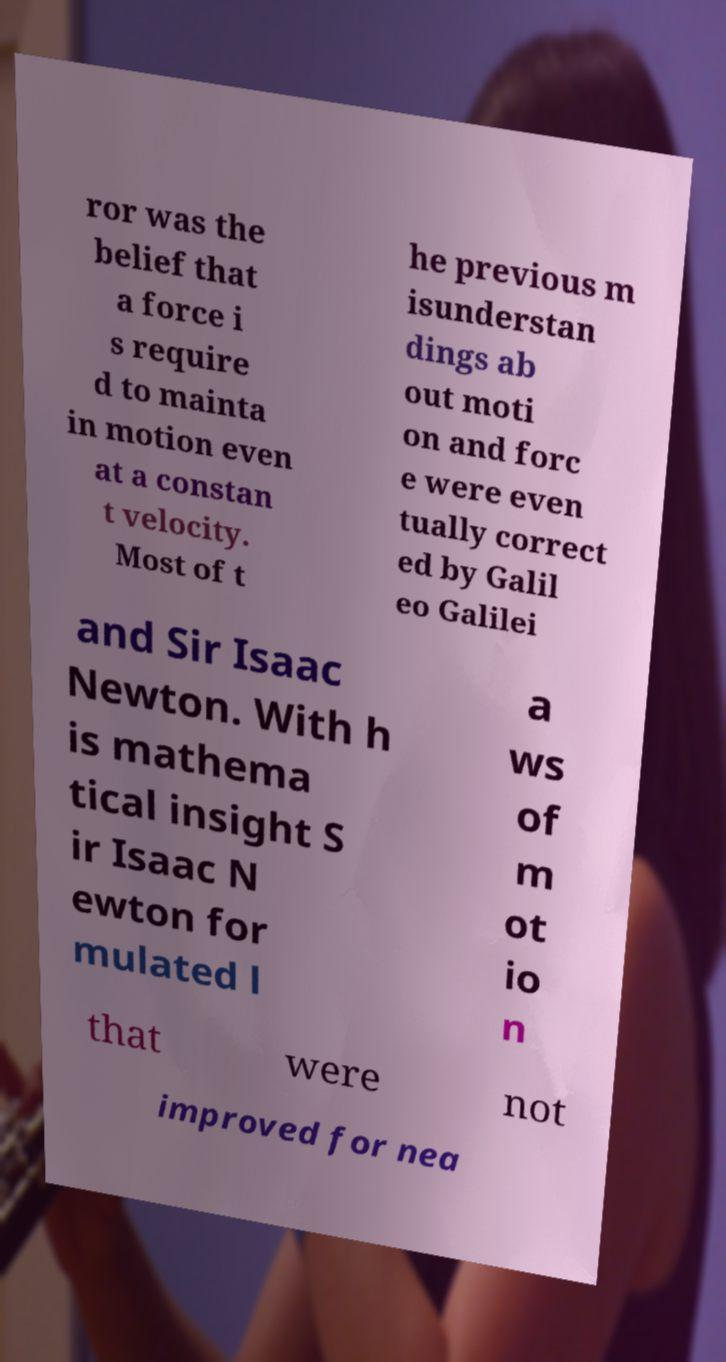Could you extract and type out the text from this image? ror was the belief that a force i s require d to mainta in motion even at a constan t velocity. Most of t he previous m isunderstan dings ab out moti on and forc e were even tually correct ed by Galil eo Galilei and Sir Isaac Newton. With h is mathema tical insight S ir Isaac N ewton for mulated l a ws of m ot io n that were not improved for nea 